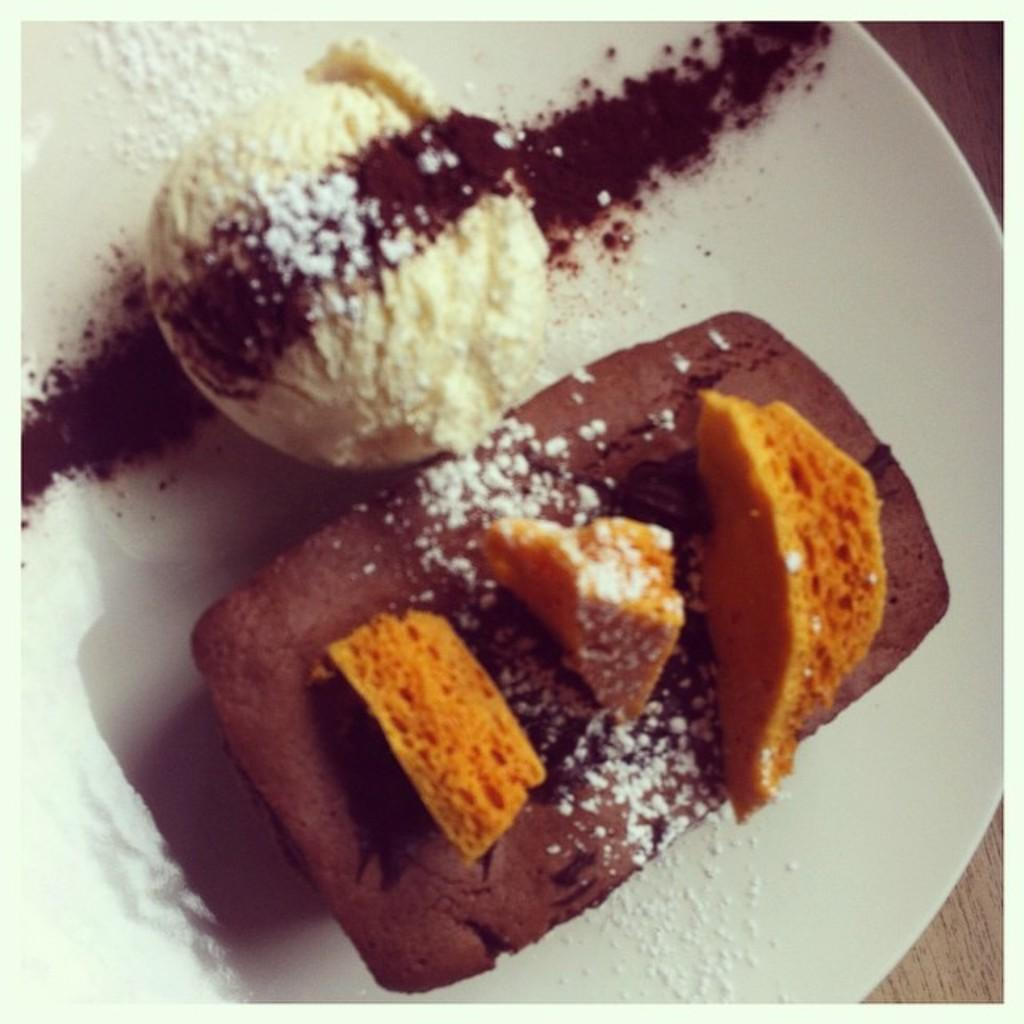What type of dessert is visible in the image? There is ice cream in the image. What other food item can be seen in the image besides the ice cream? There is another food item in the image, but its specific type is not mentioned in the facts. What color is the plate that holds the food items? The plate is white. How many family members are present in the image? There is no information about family members in the image, as the facts only mention ice cream, another food item, and the color of the plate. 